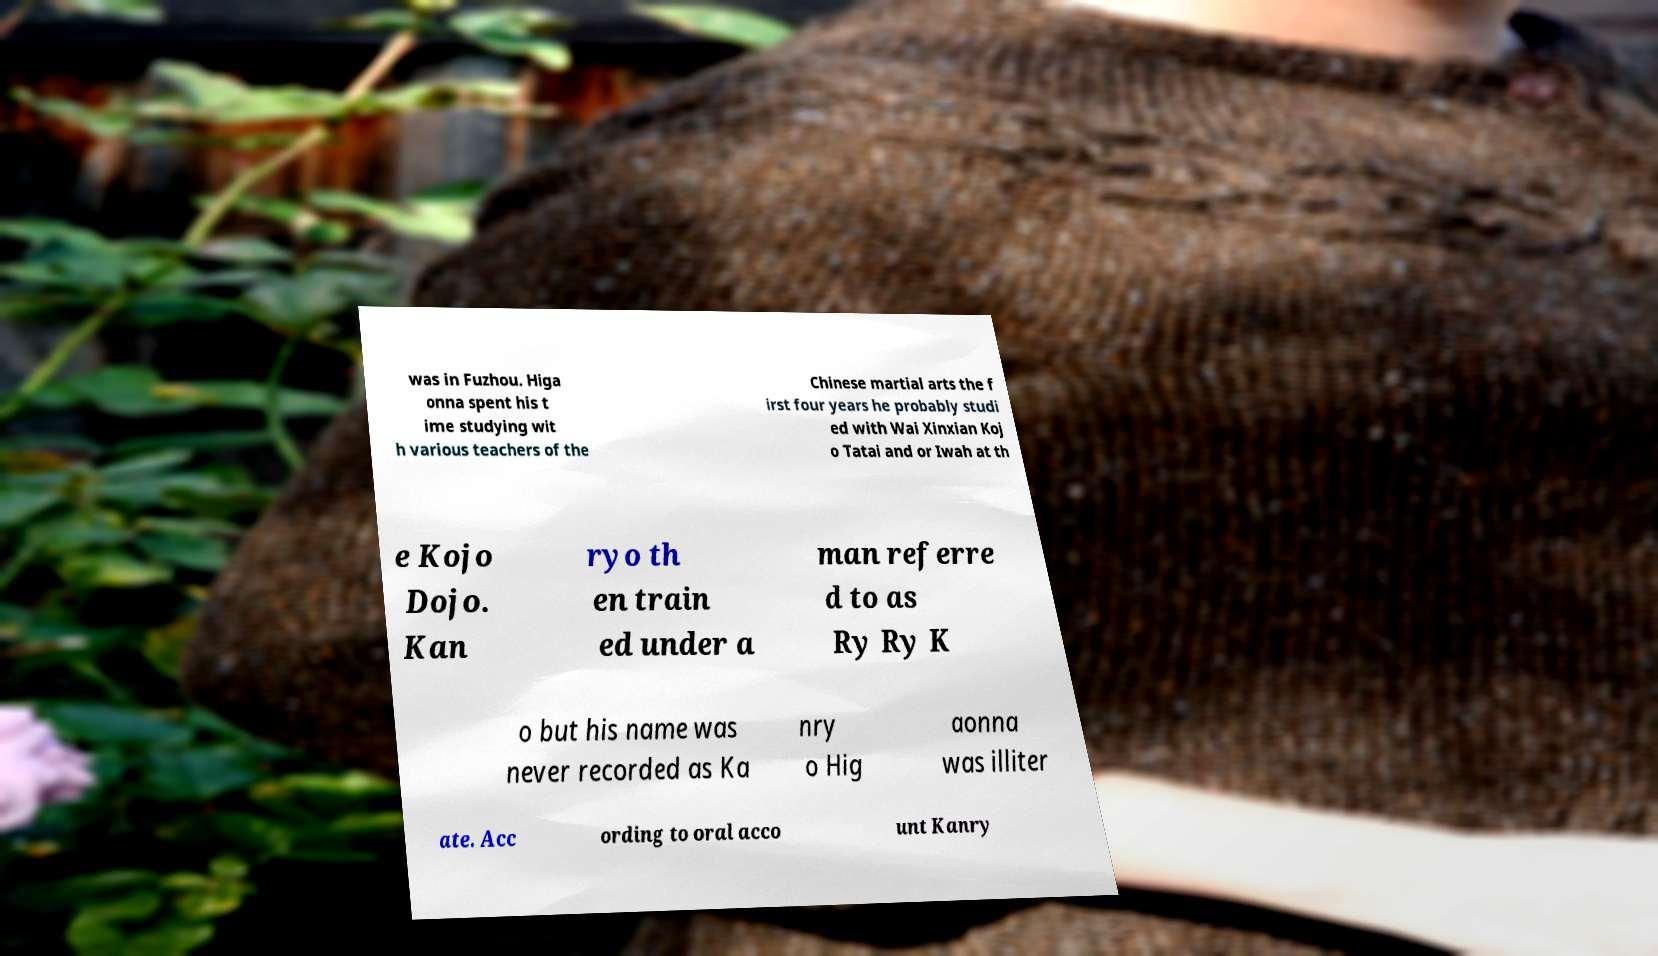Could you assist in decoding the text presented in this image and type it out clearly? was in Fuzhou. Higa onna spent his t ime studying wit h various teachers of the Chinese martial arts the f irst four years he probably studi ed with Wai Xinxian Koj o Tatai and or Iwah at th e Kojo Dojo. Kan ryo th en train ed under a man referre d to as Ry Ry K o but his name was never recorded as Ka nry o Hig aonna was illiter ate. Acc ording to oral acco unt Kanry 